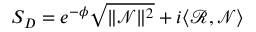<formula> <loc_0><loc_0><loc_500><loc_500>S _ { D } = e ^ { - \phi } \sqrt { \| \mathcal { N } \| ^ { 2 } } + i \langle \mathcal { R } , \mathcal { N } \rangle</formula> 